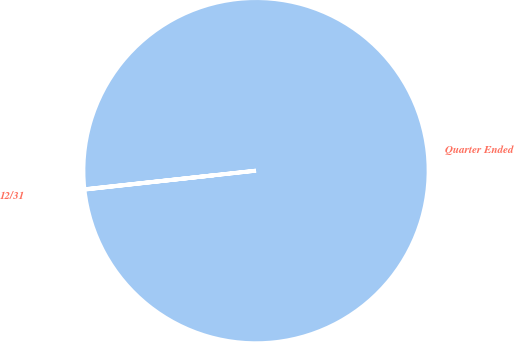<chart> <loc_0><loc_0><loc_500><loc_500><pie_chart><fcel>Quarter Ended<fcel>12/31<nl><fcel>99.97%<fcel>0.03%<nl></chart> 